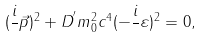<formula> <loc_0><loc_0><loc_500><loc_500>( \frac { i } { } \vec { p } ) ^ { 2 } + D ^ { ^ { \prime } } m _ { 0 } ^ { 2 } c ^ { 4 } ( - \frac { i } { } \varepsilon ) ^ { 2 } = 0 ,</formula> 